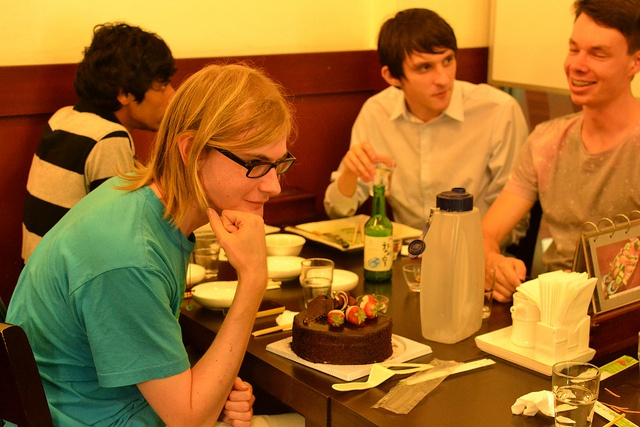Describe the objects in this image and their specific colors. I can see people in gold, red, darkgreen, and green tones, dining table in gold, orange, maroon, and brown tones, people in gold, orange, red, and maroon tones, people in gold, red, orange, and maroon tones, and people in gold, black, orange, and red tones in this image. 